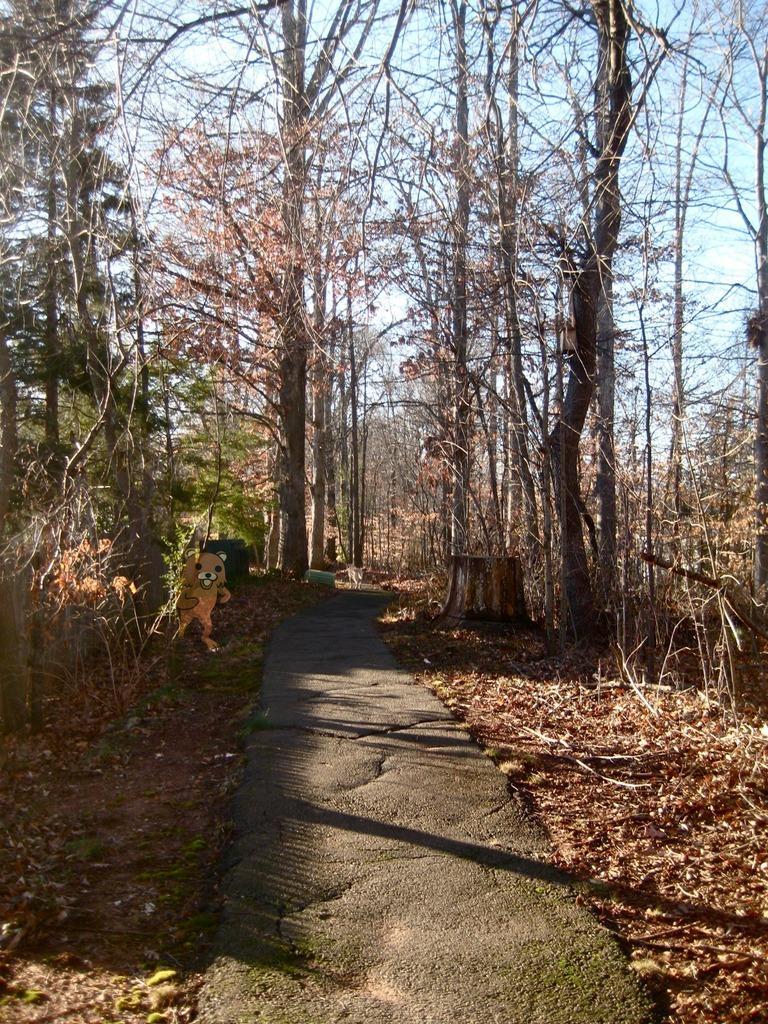Can you describe this image briefly? In this picture I can see there is a walk way here and there are few dry leaves here on to right and left side. There is a picture of a bear here and there are few tree trunks which are cut and there are plants, trees and the sky is clear. 